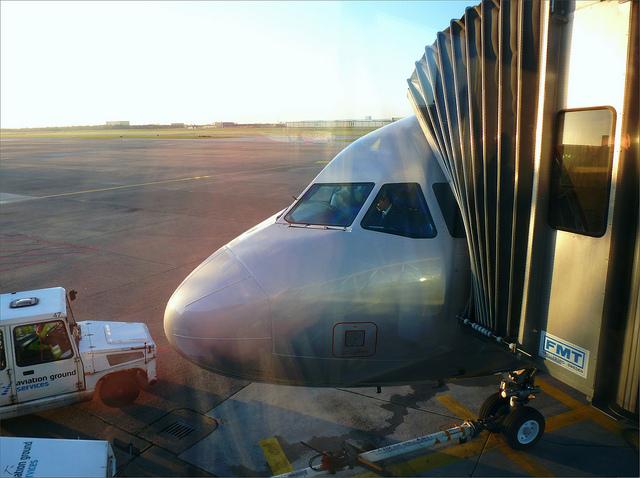Did the plane get attached to a tube?
Be succinct. Yes. Is it raining?
Answer briefly. No. What color is the plane?
Short answer required. Silver. Is there a truck in the picture?
Quick response, please. Yes. 